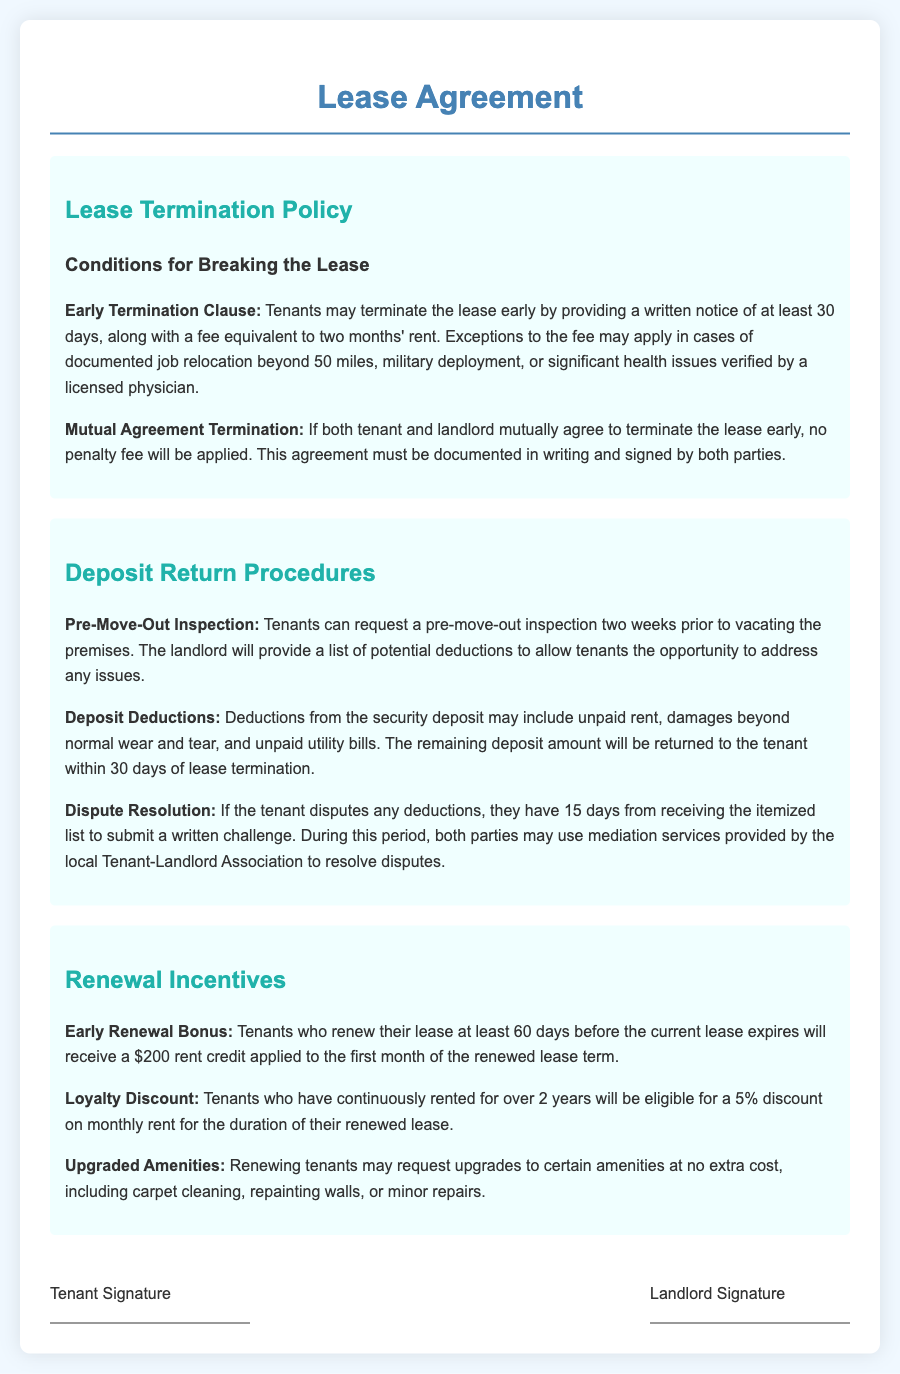What is the notice period for early termination? The document states that tenants must provide a written notice of at least 30 days for early termination.
Answer: 30 days What is the penalty fee for breaking the lease early? The lease agreement specifies a fee equivalent to two months' rent for early termination, unless exceptions apply.
Answer: Two months' rent What conditions allow for exception to the termination fee? The exceptions to the fee include documented job relocation beyond 50 miles, military deployment, or significant health issues verified by a licensed physician.
Answer: Exceptions include job relocation, military deployment, health issues How long does a tenant have to dispute deposit deductions? Tenants have 15 days from receiving the itemized list to submit a written challenge regarding the deductions.
Answer: 15 days What is the timeline for requesting a pre-move-out inspection? Tenants can request a pre-move-out inspection two weeks prior to vacating the premises.
Answer: Two weeks What is the amount of the early renewal bonus? The early renewal bonus for renewing the lease at least 60 days before expiration is $200.
Answer: $200 How long must a tenant have rented to qualify for the loyalty discount? The loyalty discount applies to tenants who have continuously rented for over 2 years.
Answer: Over 2 years What benefits may renewing tenants request? Renewing tenants may request upgrades to certain amenities, including carpet cleaning, repainting walls, or minor repairs.
Answer: Upgrades to amenities What is the timeframe for both parties to agree on early lease termination? The agreement must be documented in writing and signed by both parties for a mutual termination without penalty.
Answer: Documented in writing and signed 